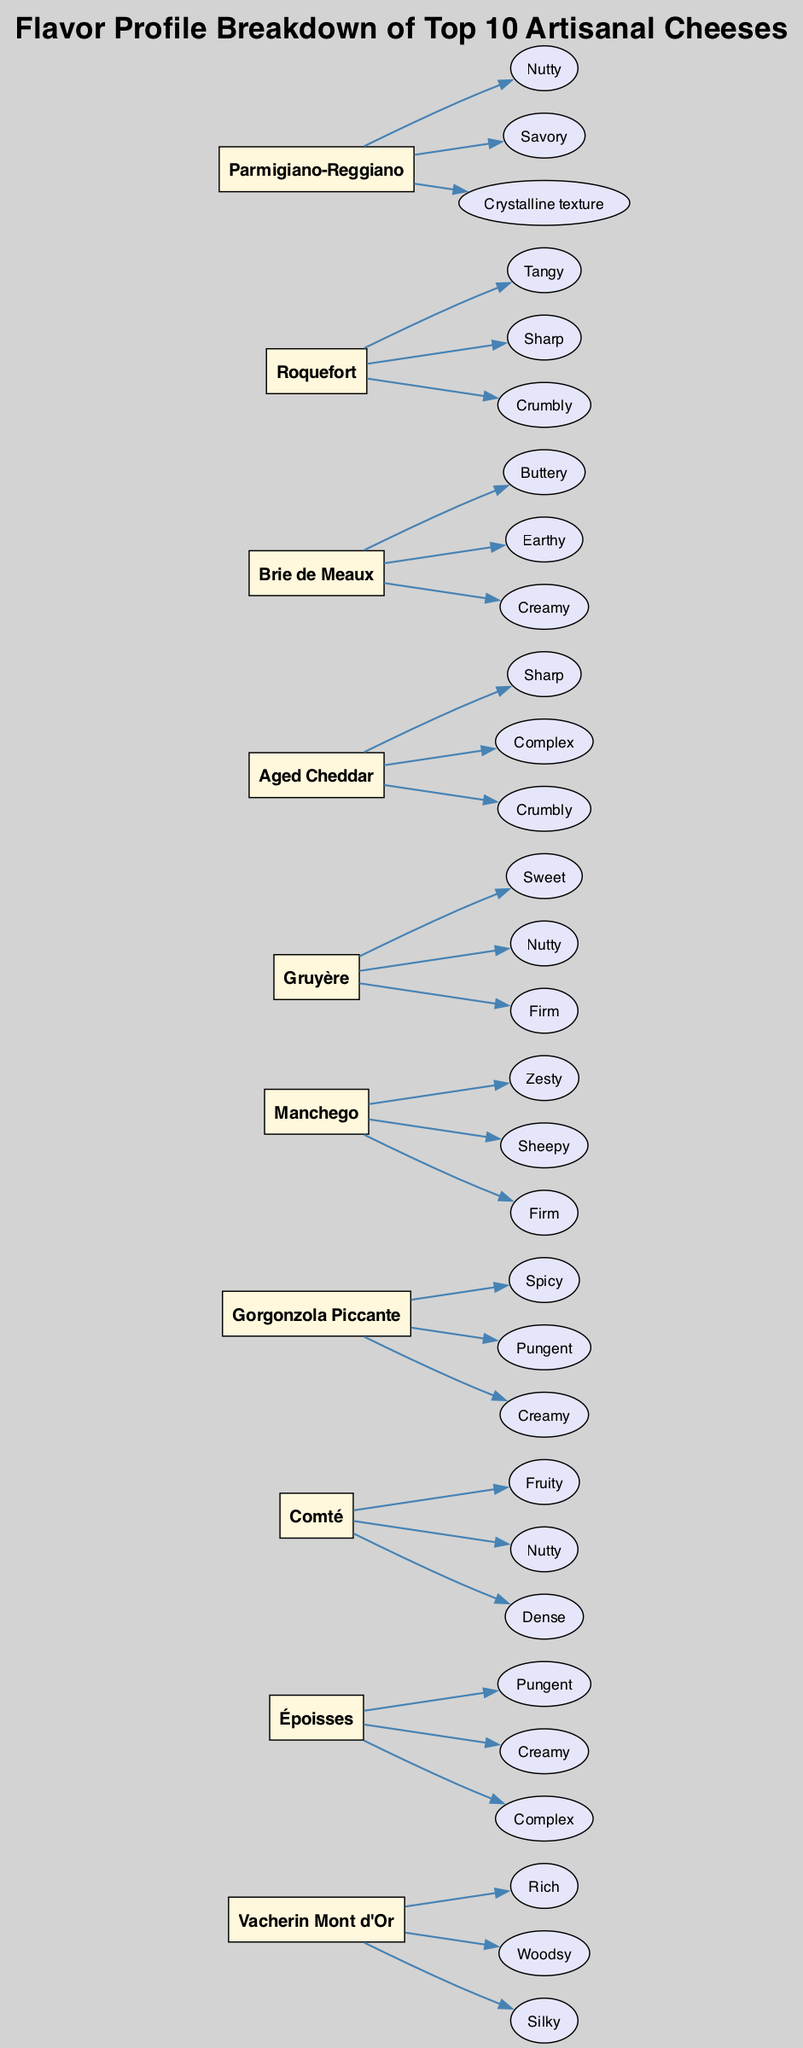What is the name of the cheese that has a nutty flavor profile? By examining the flavor profiles listed in the diagram, "Nutty" is associated with "Parmigiano-Reggiano," as it is explicitly mentioned in the profile section for that cheese.
Answer: Parmigiano-Reggiano Which cheese has the flavor profile described as "Tangy"? The diagram indicates that "Roquefort" is the cheese characterized by the flavor "Tangy," listed directly under its flavor profile section.
Answer: Roquefort How many cheeses are displayed in the diagram? The diagram displays a total of 10 cheese nodes, as indicated by the number of unique boxes for each cheese listed, confirming the count of cheeses represented.
Answer: 10 Which cheese profile includes both "Spicy" and "Creamy"? Upon reviewing the flavor profiles, the cheese "Gorgonzola Piccante" includes both "Spicy" and "Creamy" in its flavor descriptions, which matches the criteria of the question.
Answer: Gorgonzola Piccante What is the flavor profile of "Époisses"? The cheese "Époisses" has a flavor profile that includes "Pungent," "Creamy," and "Complex," all of which are listed under its section in the diagram.
Answer: Pungent, Creamy, Complex Is there a cheese that has both a "Firm" texture and a "Nutty" flavor? Looking through the profiles, "Gruyère" directly presents as "Firm" while "Nutty" is also a flavor for "Parmigiano-Reggiano." However, they are associated with different cheeses, confirming that there is no single cheese with both characteristics.
Answer: No Which cheese is identified with a "Woodsy" flavor? The diagram clearly states that "Vacherin Mont d'Or" is associated with the "Woodsy" flavor, as it is included in its outlined flavor profile.
Answer: Vacherin Mont d'Or How many flavors does "Aged Cheddar" have? The cheese "Aged Cheddar" has a total of three flavors listed: "Sharp," "Complex," and "Crumbly," counted directly from the flavor nodes connected to it in the diagram.
Answer: 3 Which cheese has the most complex flavor profile as indicated in the diagram? By examining the flavor profiles, "Époisses" is explicitly described as having a "Complex" flavor, among others, which could suggest it has a multi-faceted profile relative to the other cheeses.
Answer: Époisses 